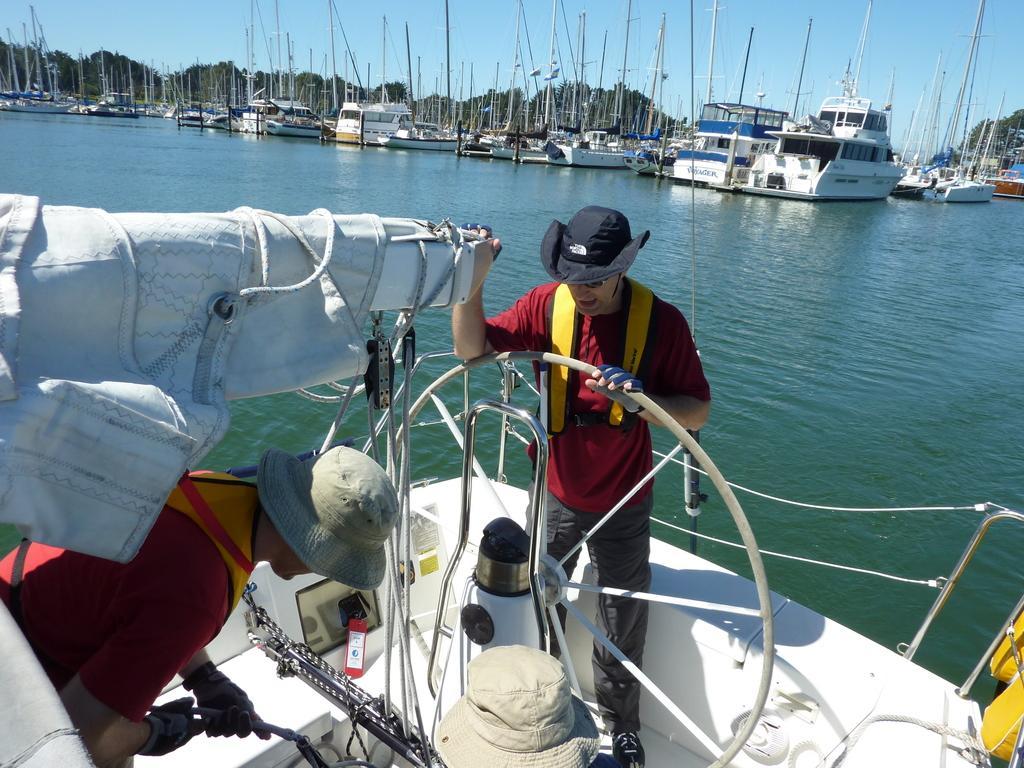Describe this image in one or two sentences. In this image we can see many watercraft. We can see the sea in the image. There are few people in the image. We can see the sky in the image. There are many trees in the image. 